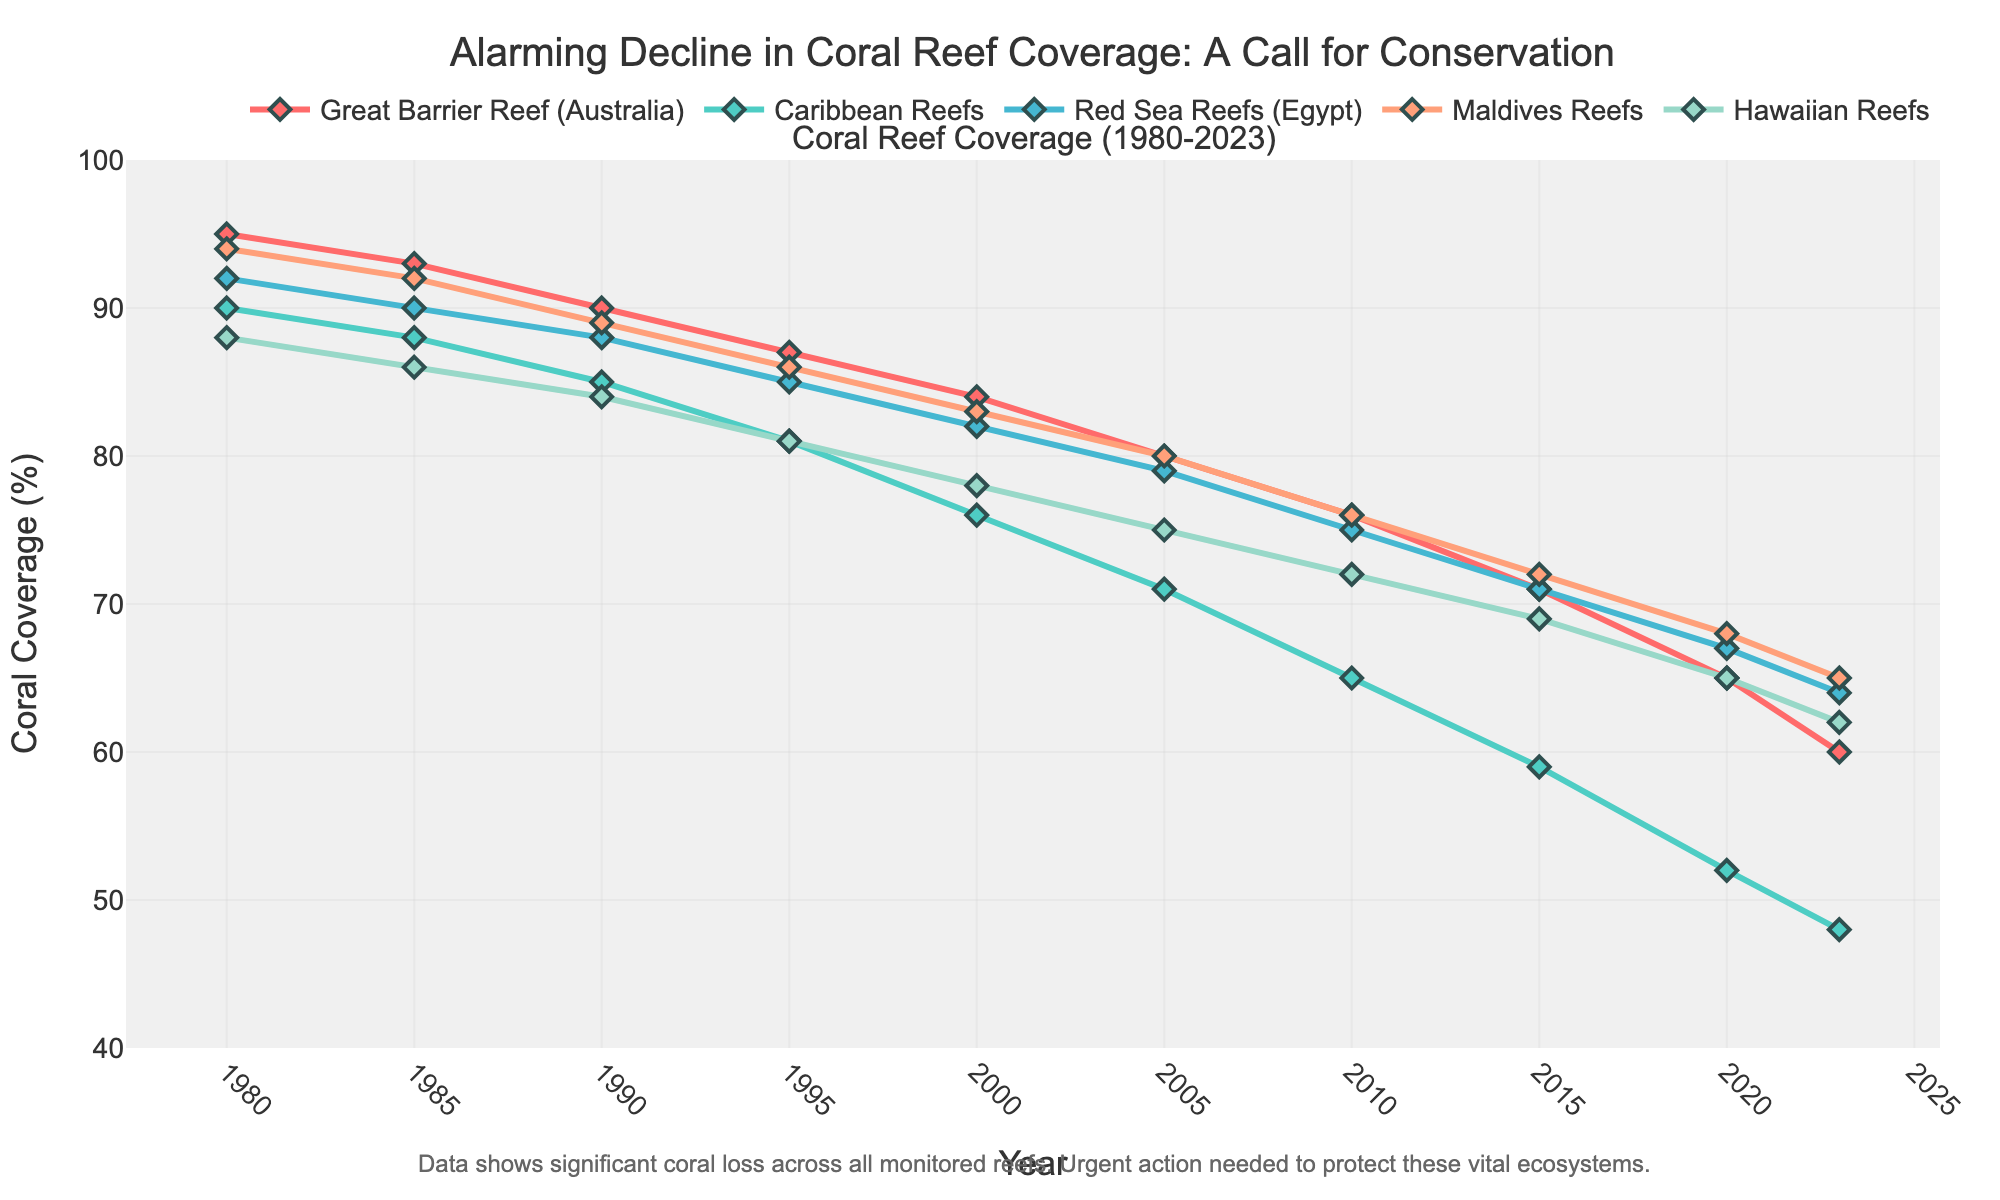What is the overall trend in coral reef coverage for the Great Barrier Reef from 1980 to 2023? The coverage percentage is decreasing over the years. Initially, it was 95% in 1980 and declines to 60% by 2023, indicating a continuous downward trend.
Answer: Decreasing In which year did the Caribbean Reefs observe the steepest decline in coral coverage? By comparing the coverage between consecutive years, the steepest decline for the Caribbean Reefs is seen between 2000 (76%) and 2005 (71%), a drop of 5%.
Answer: 2000-2005 Which coral reef had the highest coverage percentage in 2023? Observing the final data points in the plot, the Maldives Reefs have the highest coverage in 2023 at 65%.
Answer: Maldives Reefs How does the coverage of Hawaiian Reefs in 2005 compare to that of Red Sea Reefs in the same year? In 2005, the coverage for Hawaiian Reefs is 75%, while for Red Sea Reefs it is 79%. Hence, the Hawaiian Reefs have less coverage compared to the Red Sea Reefs by 4 percentage points.
Answer: Hawaiian Reefs have less coverage What is the average coral coverage percentage for the Maldives Reefs across the entire period? Sum up all coverage percentages for Maldives Reefs from 1980 to 2023: 94 + 92 + 89 + 86 + 83 + 80 + 76 + 72 + 68 + 65 = 805. Then, divide by the number of data points (10). The average is 805/10 = 80.5.
Answer: 80.5% Between 1995 and 2010, which reef showed the least decline in coverage percentage? Calculate the difference in coverage between 1995 and 2010 for each reef: 
- Great Barrier Reef: 87 - 76 = 11
- Caribbean Reefs: 81 - 65 = 16
- Red Sea Reefs: 85 - 75 = 10
- Maldives Reefs: 86 - 76 = 10
- Hawaiian Reefs: 81 - 72 = 9
The Hawaiian Reefs show the least decline of 9 percentage points.
Answer: Hawaiian Reefs By how many percentage points did the Great Barrier Reef coverage decrease from 1980 to 2023? Calculate the difference in coverage from 1980 to 2023 for the Great Barrier Reef: 95% - 60% = 35 percentage points.
Answer: 35 percentage points Identify the years during which all reefs had a decline in coverage compared to the previous year. Check each year and compare the coverage to the previous year for all reefs:
- 1985: All declined
- 1990: All declined
- 1995: All declined
- 2000: All declined
- 2005: All declined
- 2010: All declined
- 2015: All declined
- 2020: All declined
- 2023: All declined
All years in the dataset show a decline.
Answer: All years in the dataset Which reef had the smallest difference in coverage percentage between 1980 and 2023? Calculate the difference in initial and final coverage for each reef:
- Great Barrier Reef: 95 - 60 = 35
- Caribbean Reefs: 90 - 48 = 42
- Red Sea Reefs: 92 - 64 = 28
- Maldives Reefs: 94 - 65 = 29
- Hawaiian Reefs: 88 - 62 = 26
The Hawaiian Reefs have the smallest difference at 26 percentage points.
Answer: Hawaiian Reefs 